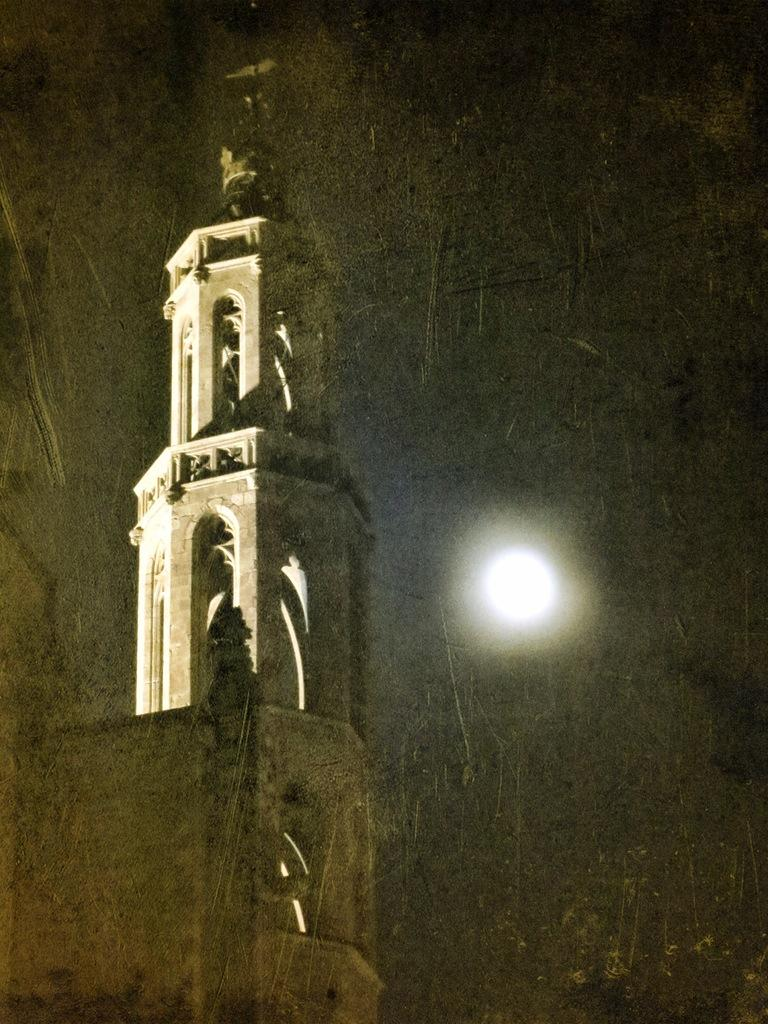What is the main structure in the front of the image? There is a tower in the front of the image. What is the color of the sky in the image? The sky is black in the image. What type of light is visible in the sky? Moonlight is visible in the sky. Where is the heart-shaped playground located in the image? There is no heart-shaped playground present in the image. Can you see the friend waving from the tower in the image? There is no friend visible in the image, and the tower is not described as having a person on it. 